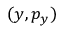Convert formula to latex. <formula><loc_0><loc_0><loc_500><loc_500>( y , p _ { y } )</formula> 